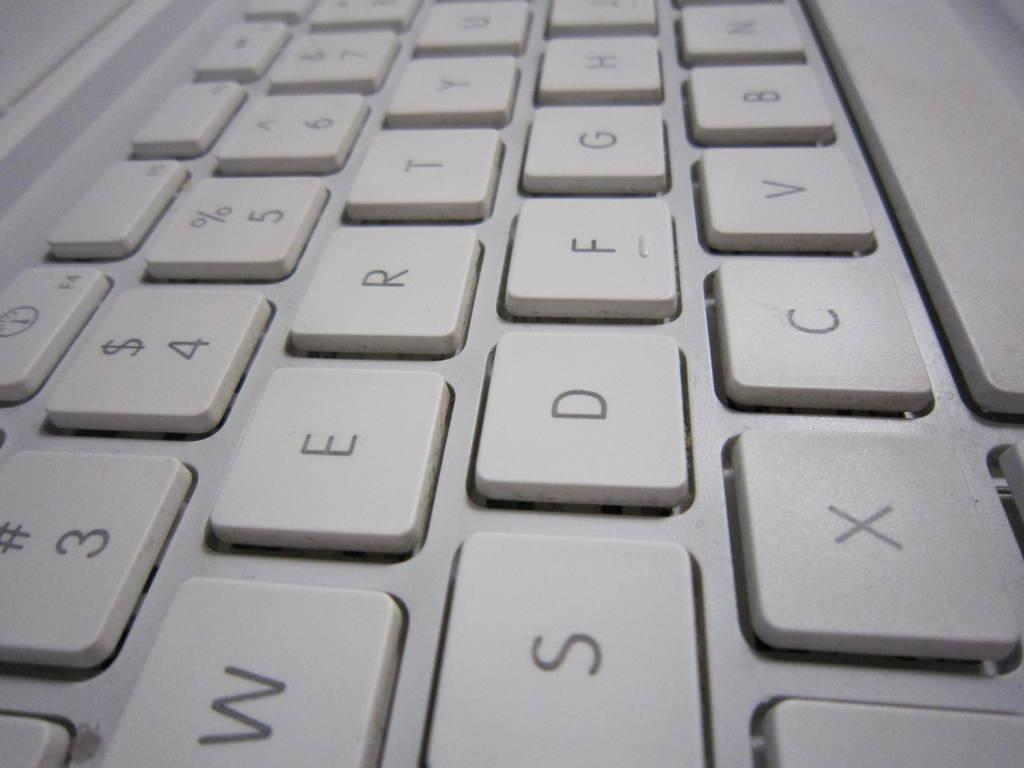<image>
Describe the image concisely. a close up of a white keyboard including keys for W, S, and X 